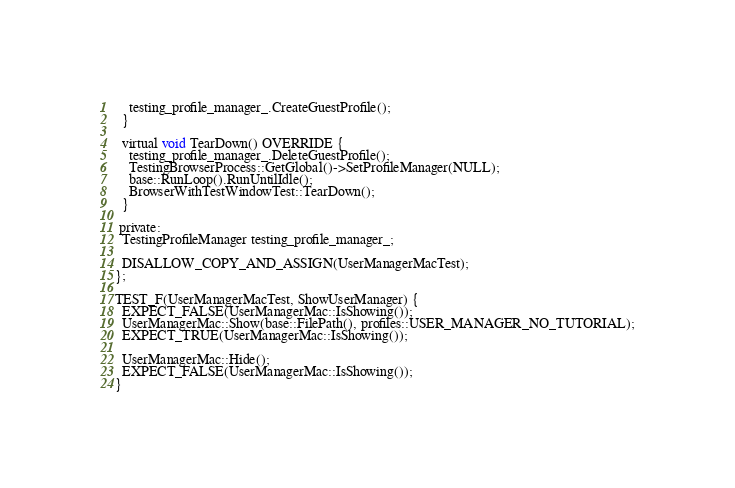<code> <loc_0><loc_0><loc_500><loc_500><_ObjectiveC_>    testing_profile_manager_.CreateGuestProfile();
  }

  virtual void TearDown() OVERRIDE {
    testing_profile_manager_.DeleteGuestProfile();
    TestingBrowserProcess::GetGlobal()->SetProfileManager(NULL);
    base::RunLoop().RunUntilIdle();
    BrowserWithTestWindowTest::TearDown();
  }

 private:
  TestingProfileManager testing_profile_manager_;

  DISALLOW_COPY_AND_ASSIGN(UserManagerMacTest);
};

TEST_F(UserManagerMacTest, ShowUserManager) {
  EXPECT_FALSE(UserManagerMac::IsShowing());
  UserManagerMac::Show(base::FilePath(), profiles::USER_MANAGER_NO_TUTORIAL);
  EXPECT_TRUE(UserManagerMac::IsShowing());

  UserManagerMac::Hide();
  EXPECT_FALSE(UserManagerMac::IsShowing());
}
</code> 